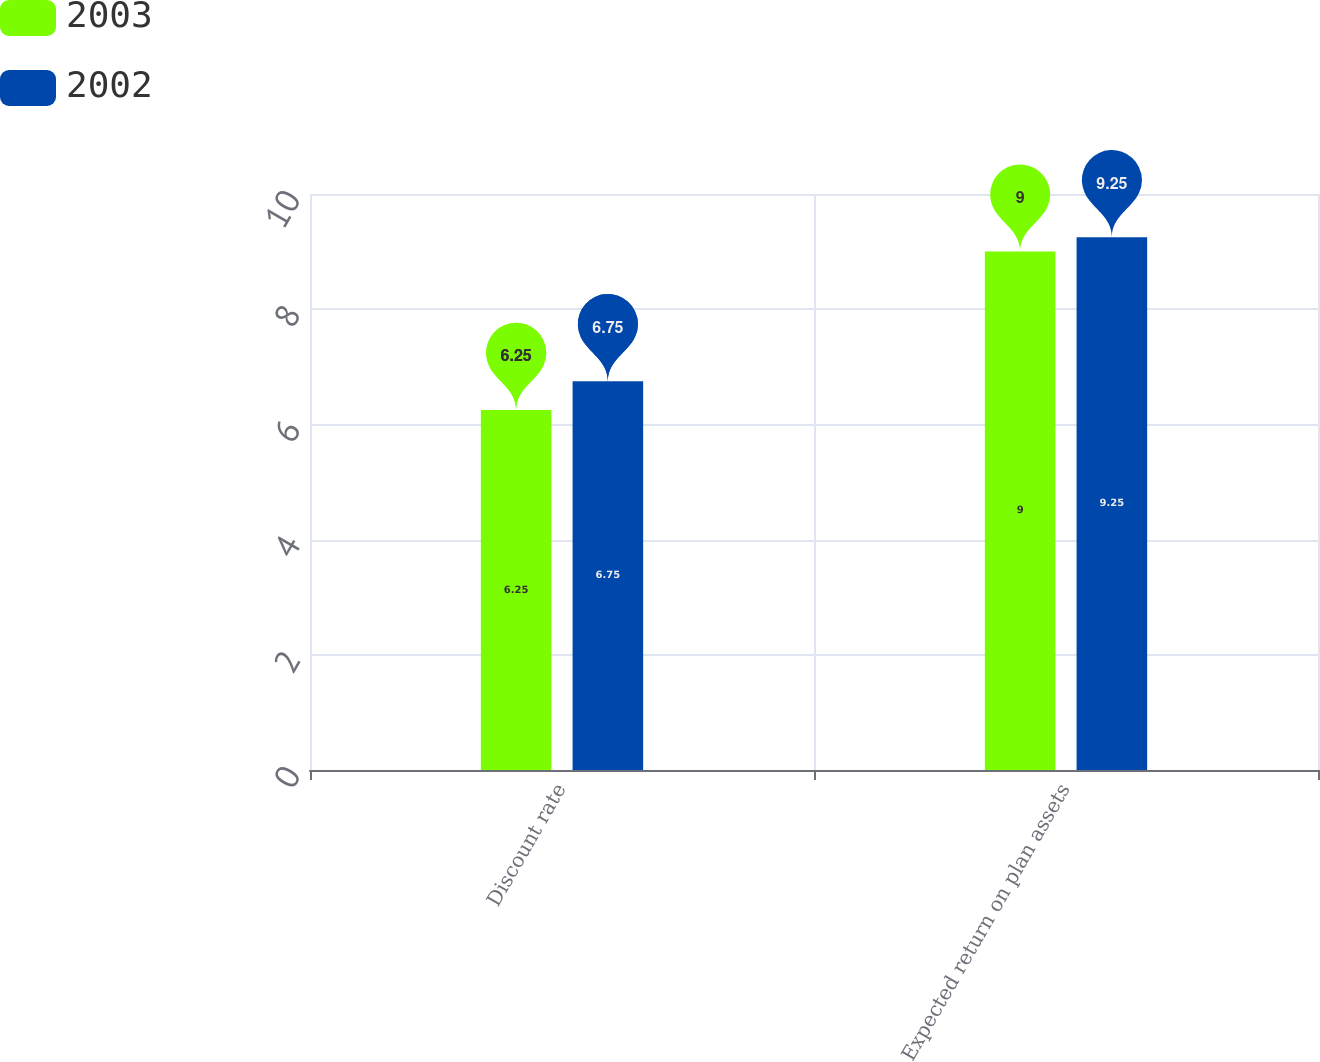<chart> <loc_0><loc_0><loc_500><loc_500><stacked_bar_chart><ecel><fcel>Discount rate<fcel>Expected return on plan assets<nl><fcel>2003<fcel>6.25<fcel>9<nl><fcel>2002<fcel>6.75<fcel>9.25<nl></chart> 